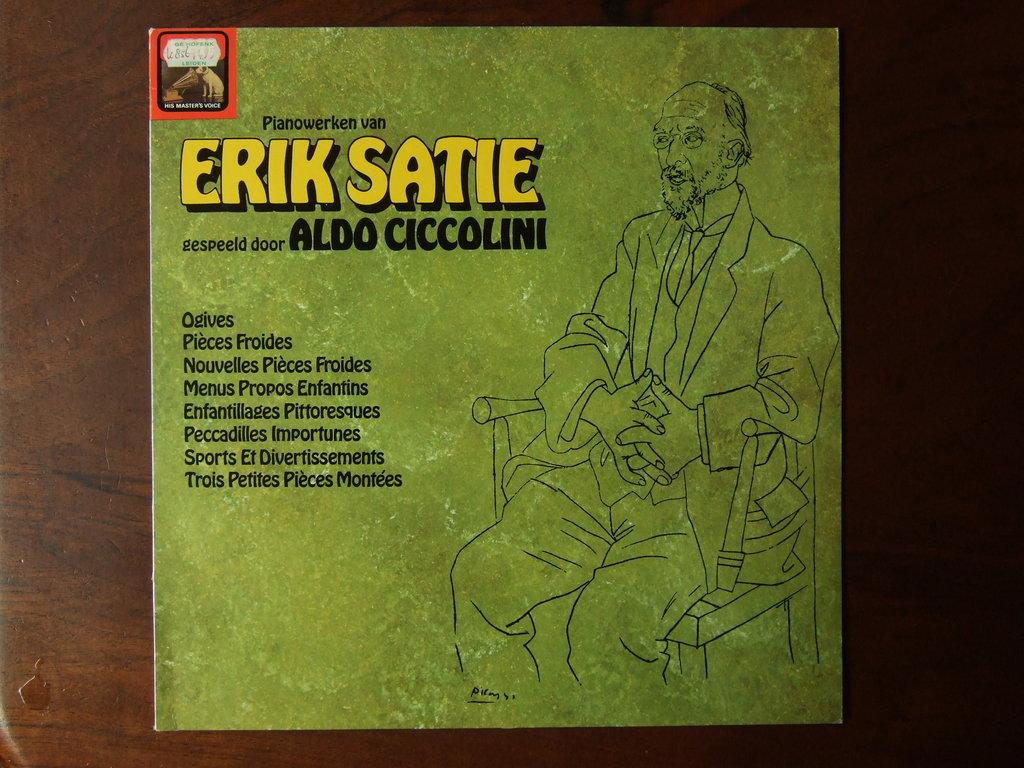Provide a one-sentence caption for the provided image. A record album by Erik Satie shows a man seated in a chair. 